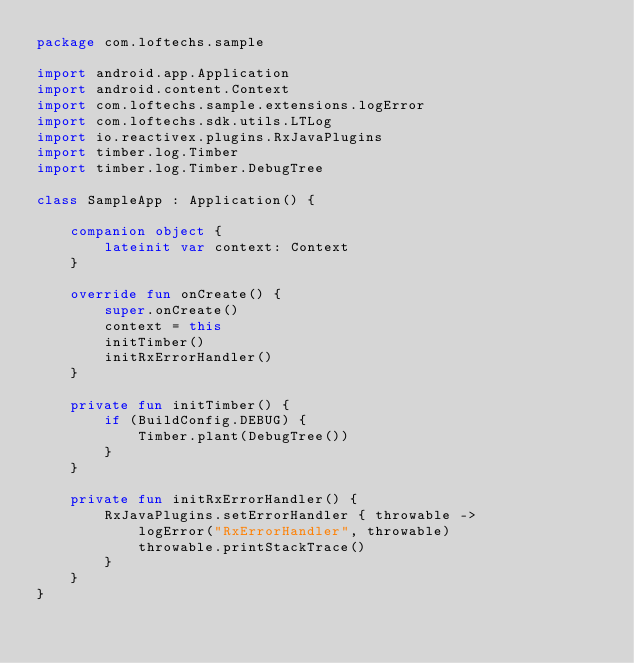Convert code to text. <code><loc_0><loc_0><loc_500><loc_500><_Kotlin_>package com.loftechs.sample

import android.app.Application
import android.content.Context
import com.loftechs.sample.extensions.logError
import com.loftechs.sdk.utils.LTLog
import io.reactivex.plugins.RxJavaPlugins
import timber.log.Timber
import timber.log.Timber.DebugTree

class SampleApp : Application() {

    companion object {
        lateinit var context: Context
    }

    override fun onCreate() {
        super.onCreate()
        context = this
        initTimber()
        initRxErrorHandler()
    }

    private fun initTimber() {
        if (BuildConfig.DEBUG) {
            Timber.plant(DebugTree())
        }
    }

    private fun initRxErrorHandler() {
        RxJavaPlugins.setErrorHandler { throwable ->
            logError("RxErrorHandler", throwable)
            throwable.printStackTrace()
        }
    }
}</code> 